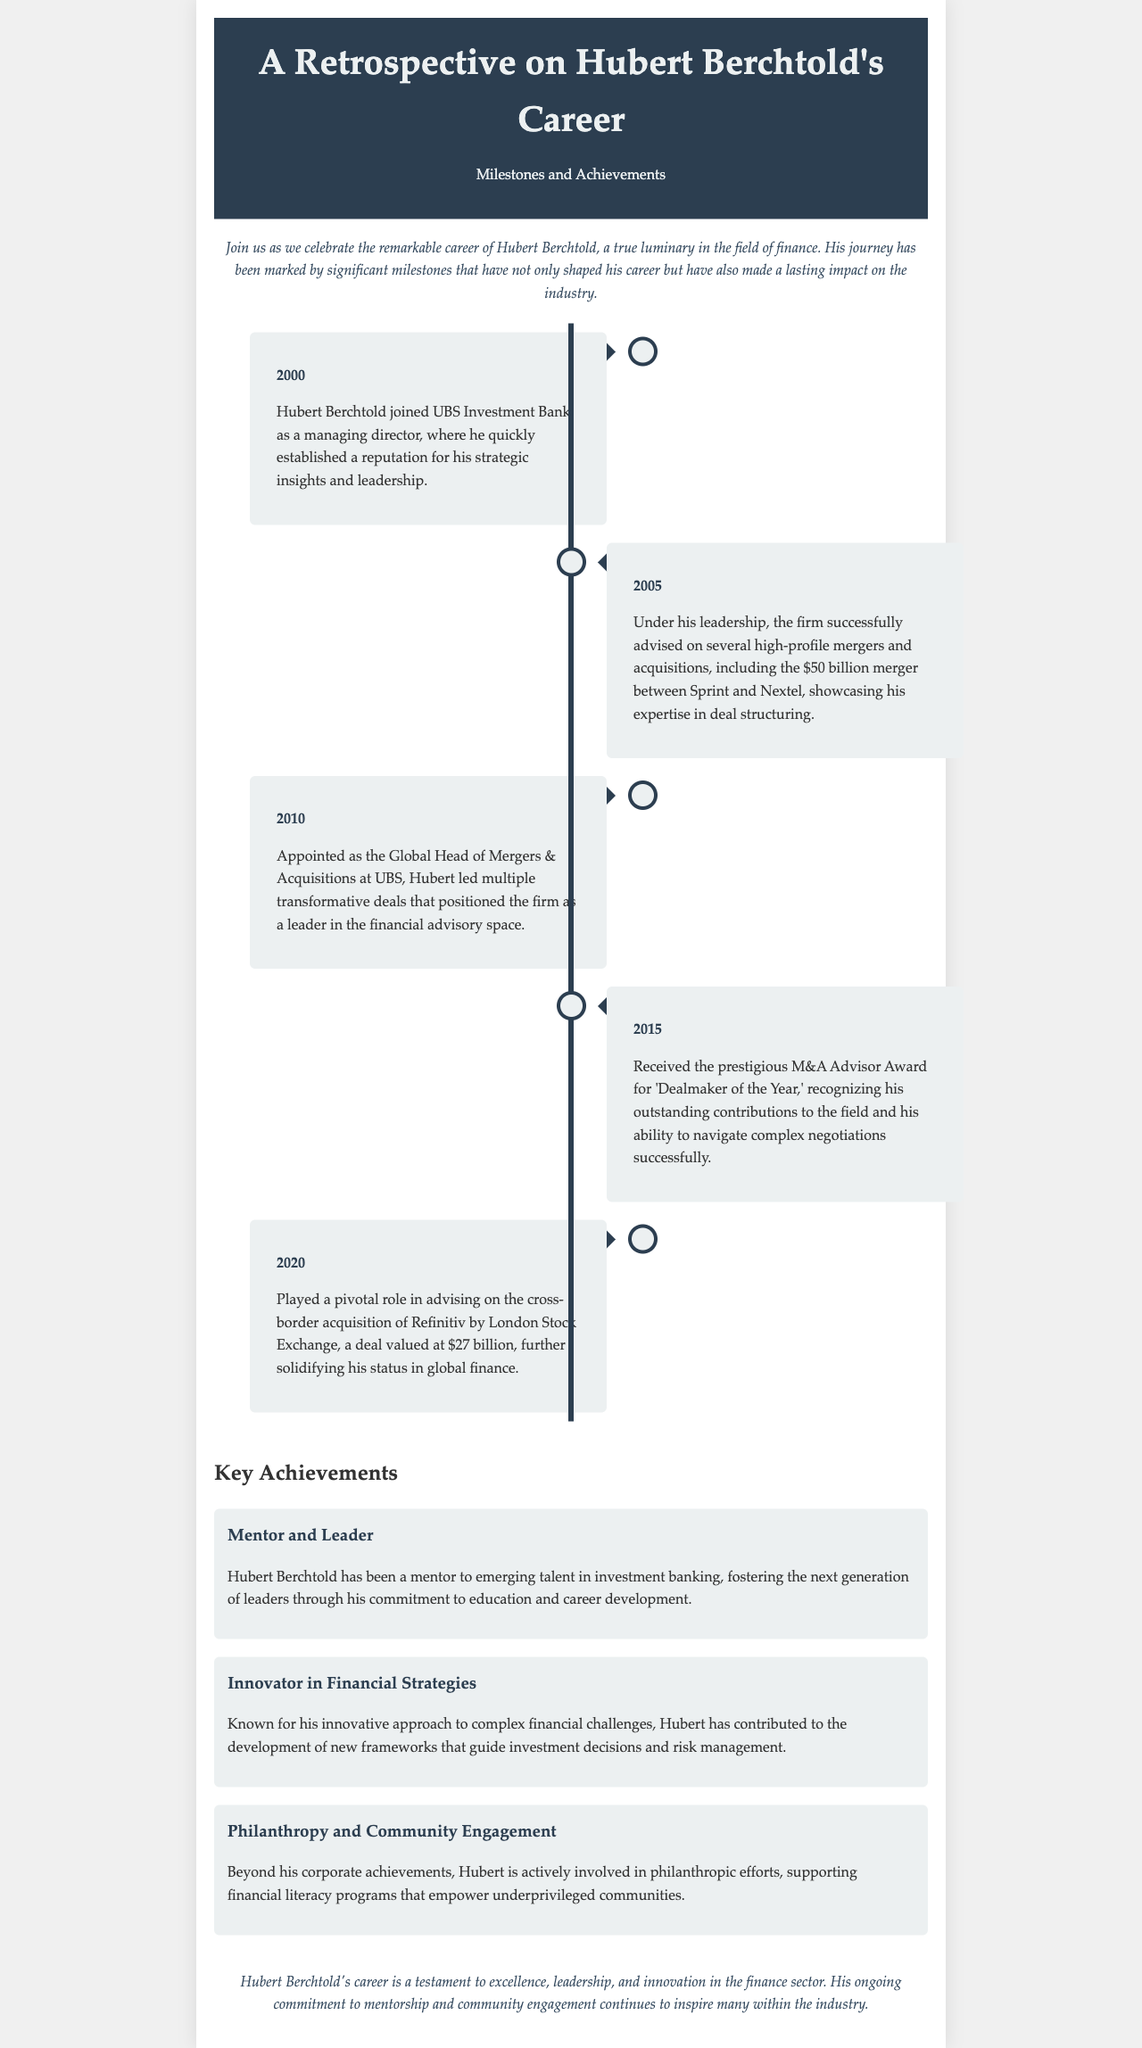What year did Hubert Berchtold join UBS Investment Bank? The document states that Hubert joined UBS Investment Bank in 2000.
Answer: 2000 What significant merger did Hubert Berchtold advise on in 2005? The document mentions the $50 billion merger between Sprint and Nextel as a key achievement in 2005.
Answer: $50 billion merger between Sprint and Nextel What title did Hubert hold in 2010? The document states he was appointed as the Global Head of Mergers & Acquisitions at UBS in 2010.
Answer: Global Head of Mergers & Acquisitions Which award did Hubert receive in 2015? The document indicates that he received the M&A Advisor Award for 'Dealmaker of the Year' in 2015.
Answer: M&A Advisor Award for 'Dealmaker of the Year' What was the value of the acquisition of Refinitiv by London Stock Exchange? The document notes that the acquisition deal was valued at $27 billion in 2020.
Answer: $27 billion What role has Hubert Berchtold played in mentoring young professionals? The document describes him as a mentor to emerging talent in investment banking.
Answer: Mentor What innovative contribution has Hubert made to the finance industry? The document highlights his innovative approach to complex financial challenges and frameworks for investment decisions.
Answer: Innovative approach to complex financial challenges What philanthropic efforts is Hubert involved in? The document states that he supports financial literacy programs for underprivileged communities as part of his community engagement.
Answer: Supporting financial literacy programs 